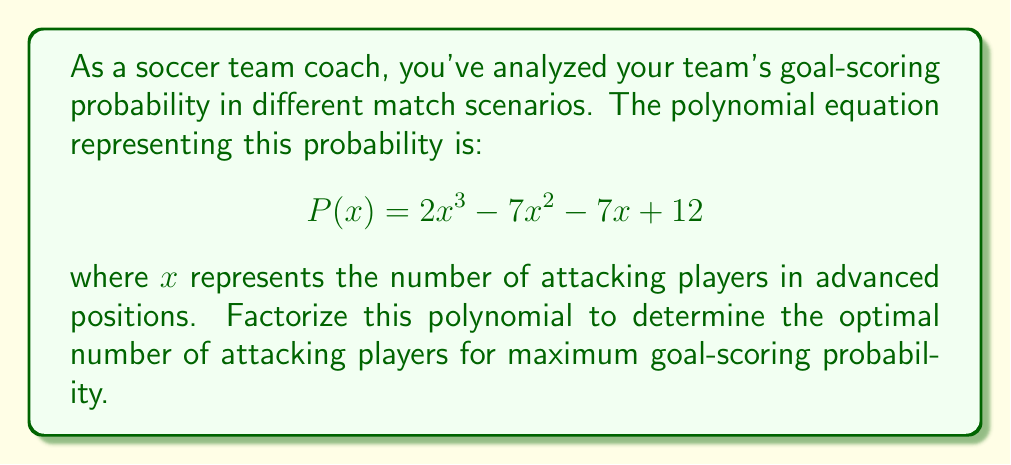Can you answer this question? Let's factorize the polynomial $P(x) = 2x^3 - 7x^2 - 7x + 12$ step by step:

1) First, let's check if there's a common factor:
   There's no common factor for all terms.

2) Next, let's try the rational root theorem. The possible rational roots are the factors of the constant term (12): ±1, ±2, ±3, ±4, ±6, ±12.

3) Testing these values, we find that x = 3 is a root.

4) Divide the polynomial by (x - 3):

   $2x^3 - 7x^2 - 7x + 12 = (x - 3)(2x^2 + ax + b)$

   Comparing coefficients:
   $2x^2: a = -1$
   $-7x: -3a + b = -7, so b = 4$

5) So we have: $2x^3 - 7x^2 - 7x + 12 = (x - 3)(2x^2 - x + 4)$

6) The quadratic factor $2x^2 - x + 4$ can be further factored using the quadratic formula:

   $x = \frac{1 \pm \sqrt{1^2 - 4(2)(4)}}{2(2)} = \frac{1 \pm \sqrt{-31}}{4}$

   This quadratic factor has no real roots.

Therefore, the complete factorization is:

$$P(x) = (x - 3)(2x^2 - x + 4)$$

This factorization shows that the only real root is x = 3, suggesting that having 3 attacking players in advanced positions optimizes the goal-scoring probability.
Answer: $(x - 3)(2x^2 - x + 4)$ 